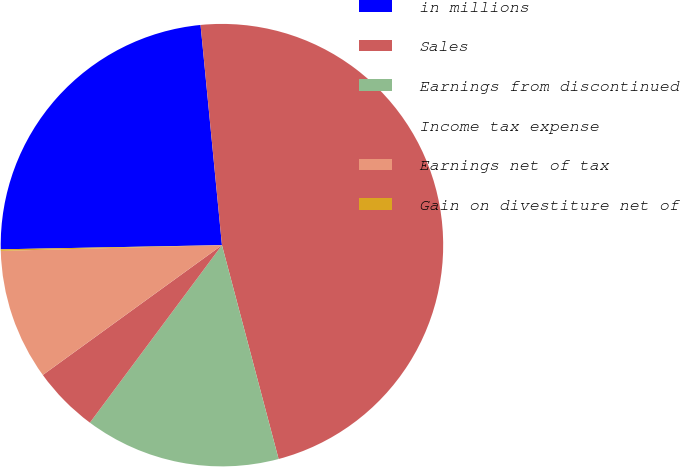Convert chart. <chart><loc_0><loc_0><loc_500><loc_500><pie_chart><fcel>in millions<fcel>Sales<fcel>Earnings from discontinued<fcel>Income tax expense<fcel>Earnings net of tax<fcel>Gain on divestiture net of<nl><fcel>23.76%<fcel>47.42%<fcel>14.3%<fcel>4.84%<fcel>9.57%<fcel>0.11%<nl></chart> 